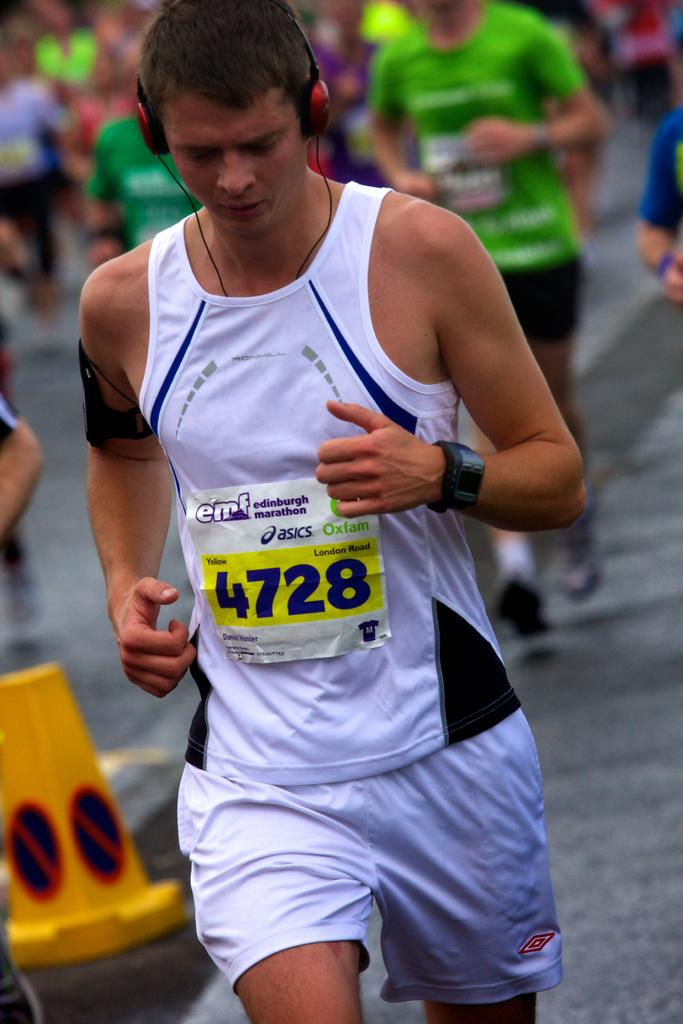<image>
Share a concise interpretation of the image provided. A young man wearking white shorts and a white vest bearing the number 4728 is running. 